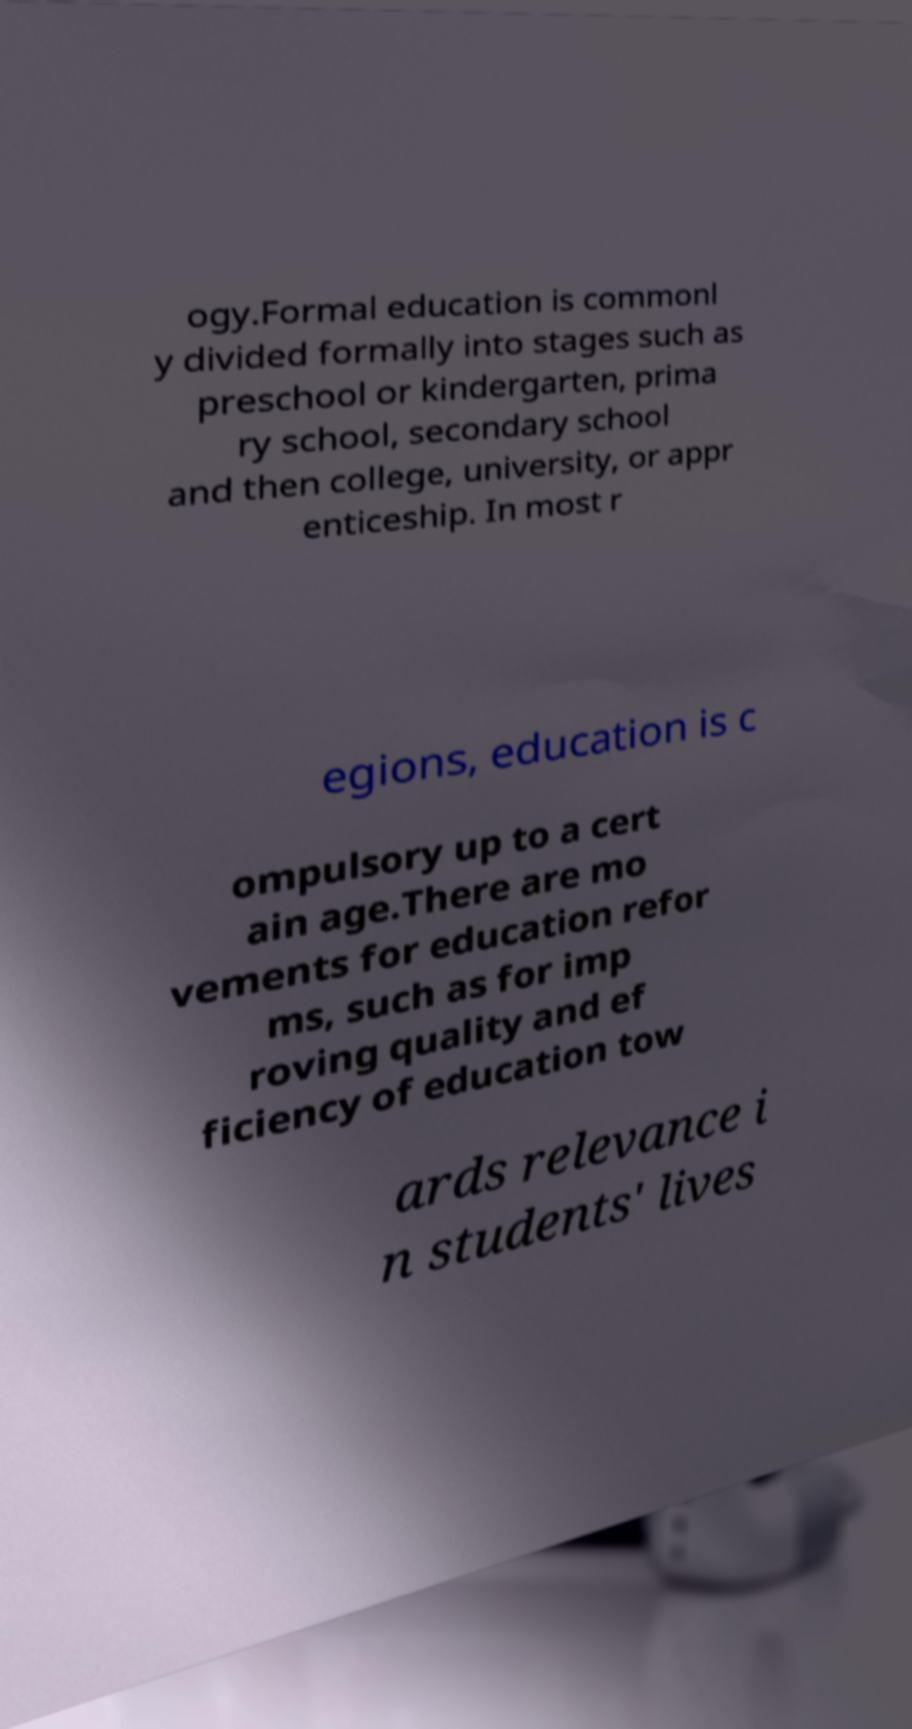Please read and relay the text visible in this image. What does it say? ogy.Formal education is commonl y divided formally into stages such as preschool or kindergarten, prima ry school, secondary school and then college, university, or appr enticeship. In most r egions, education is c ompulsory up to a cert ain age.There are mo vements for education refor ms, such as for imp roving quality and ef ficiency of education tow ards relevance i n students' lives 